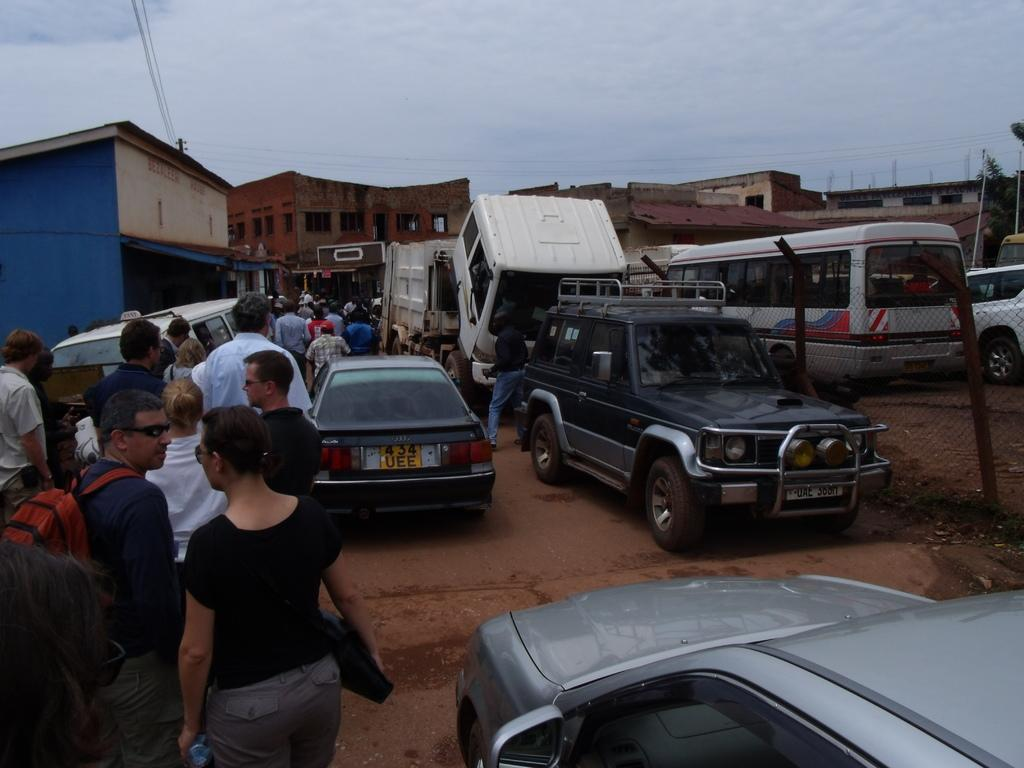What type of structures can be seen in the image? There are buildings in the image. What else is present in the image besides buildings? There are vehicles and a group of people in the image. Where are the people located in the image? The group of people is at the bottom of the image. What can be seen in the background of the image? The sky is visible in the background of the image. How much salt is being transported by the vehicles in the image? There is no information about salt or any specific cargo being transported by the vehicles in the image. Can you see any veins in the group of people in the image? The image does not provide enough detail to identify individual veins in the group of people. 